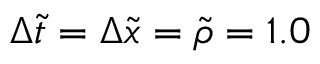<formula> <loc_0><loc_0><loc_500><loc_500>\Delta \tilde { t } = \Delta \tilde { x } = \tilde { \rho } = 1 . 0</formula> 